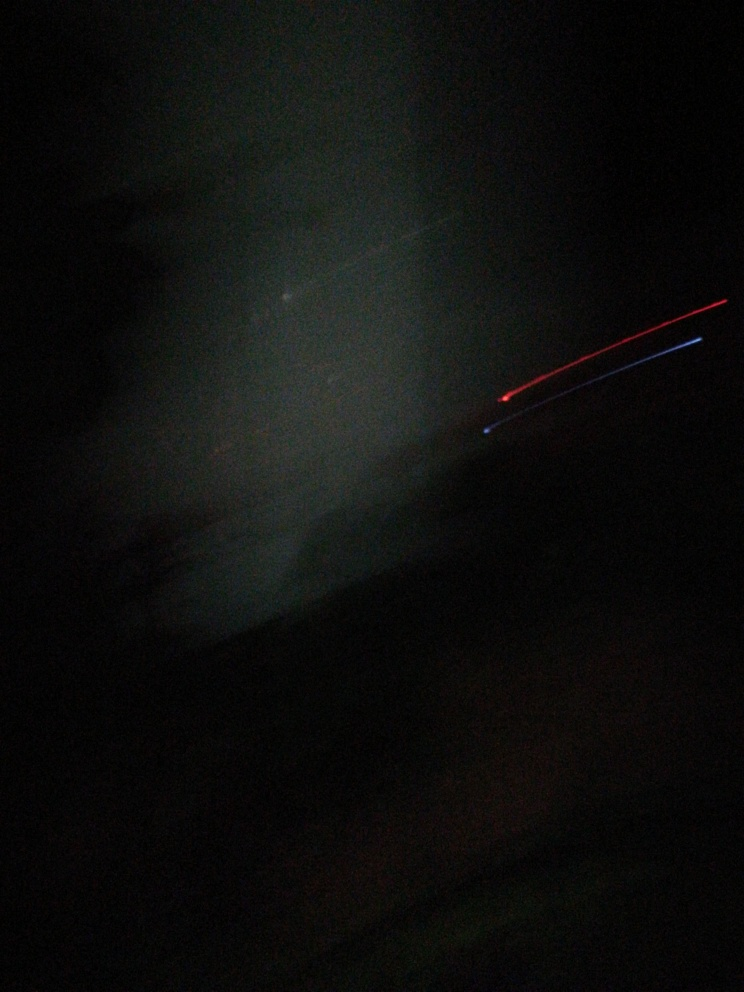What could have caused the red and blue streaks in the image? The red and blue streaks in the photograph are likely caused by light sources, such as car tail lights or LED lights, which moved relative to the camera during a long exposure. This is a common effect when capturing photos in low light without a stable camera position. 